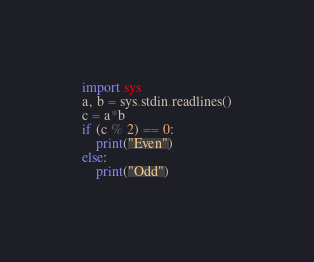<code> <loc_0><loc_0><loc_500><loc_500><_Python_>import sys
a, b = sys.stdin.readlines()
c = a*b
if (c % 2) == 0:
    print("Even")
else:
    print("Odd")</code> 